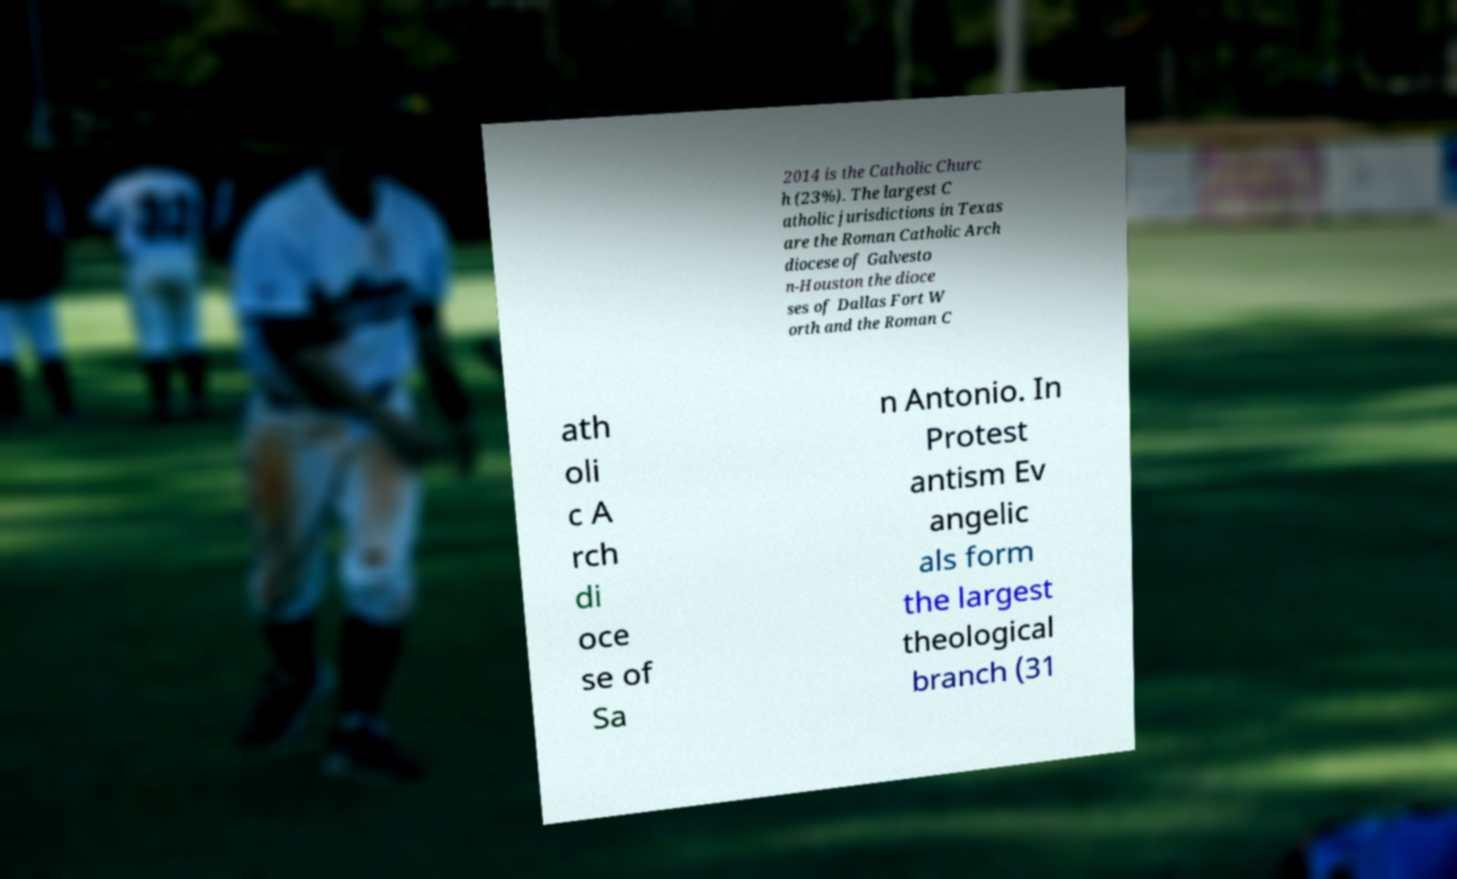Can you read and provide the text displayed in the image?This photo seems to have some interesting text. Can you extract and type it out for me? 2014 is the Catholic Churc h (23%). The largest C atholic jurisdictions in Texas are the Roman Catholic Arch diocese of Galvesto n-Houston the dioce ses of Dallas Fort W orth and the Roman C ath oli c A rch di oce se of Sa n Antonio. In Protest antism Ev angelic als form the largest theological branch (31 